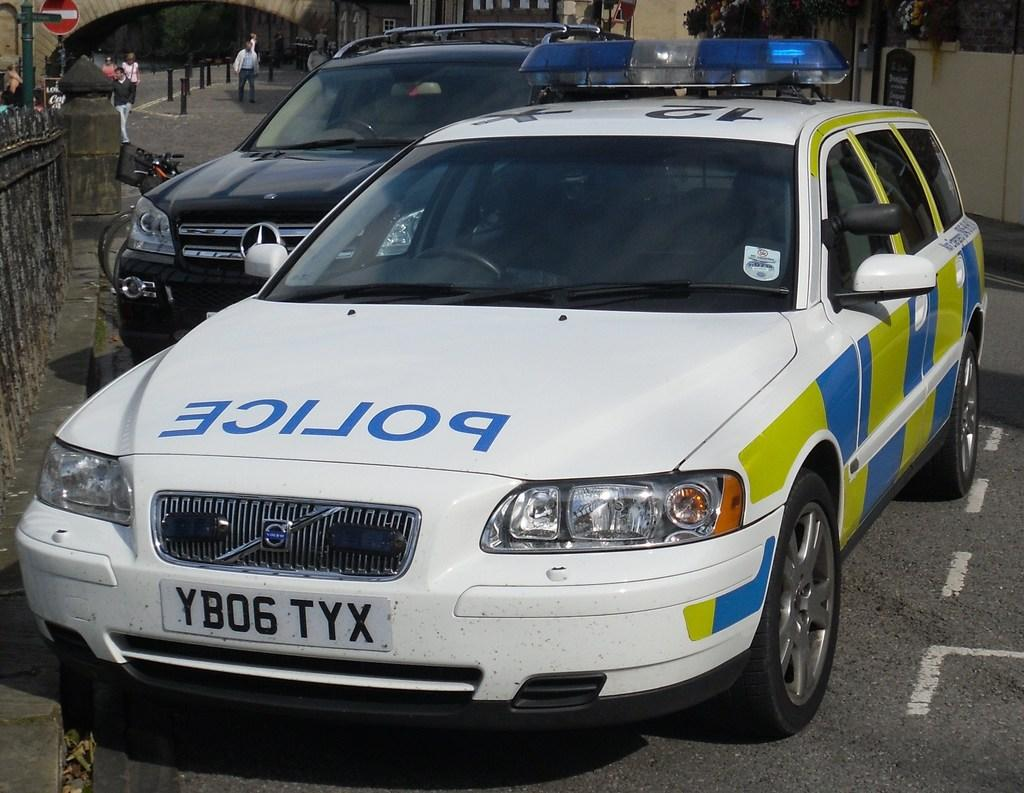What type of objects can be seen in the image that are used to control traffic? There are barrier poles in the image that are used to control traffic. What type of structures can be seen in the image? There are buildings in the image. What type of natural elements can be seen in the image? There are plants in the image. What type of human activity can be seen in the image? There are persons walking on the road in the image. What type of transportation is present in the image? Motor vehicles are present in the image. What type of sound can be heard coming from the game in the image? There is no game present in the image, so no such sound can be heard. What type of brain activity can be observed in the image? There is no reference to brain activity in the image, as it features barrier poles, buildings, plants, persons walking, and motor vehicles. 